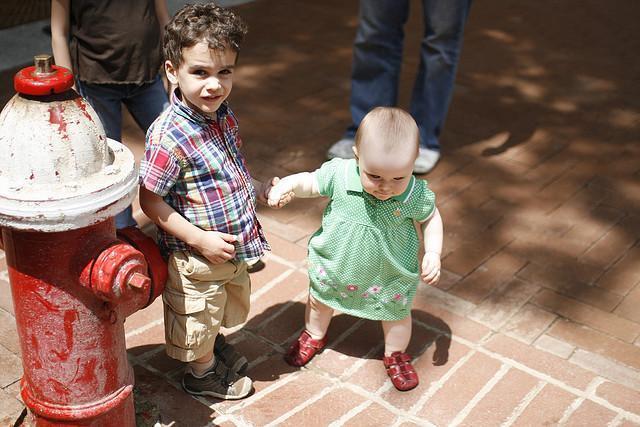How many people can you see?
Give a very brief answer. 4. 